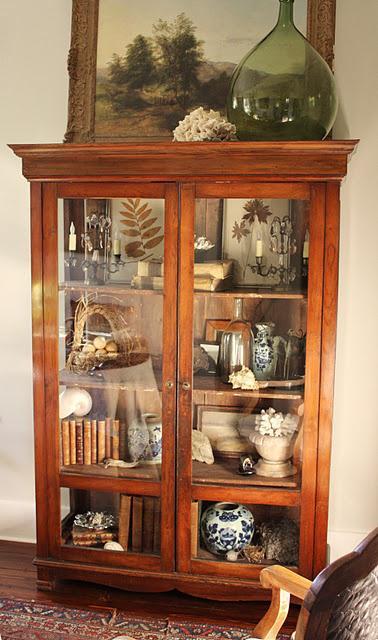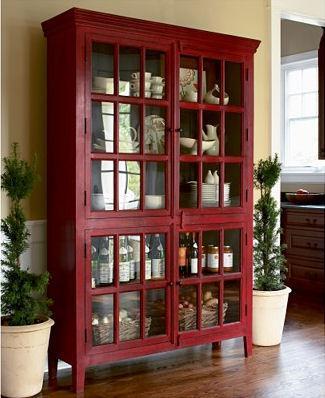The first image is the image on the left, the second image is the image on the right. For the images shown, is this caption "There is at least one deep red cabinet with legs." true? Answer yes or no. Yes. 